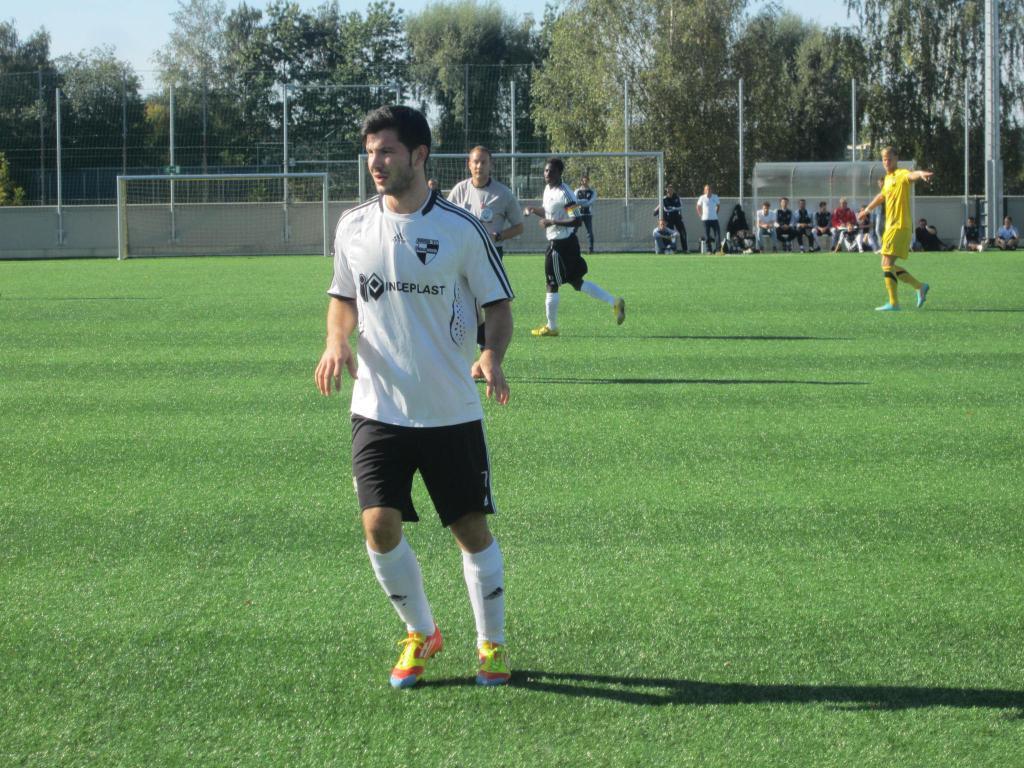Can you describe this image briefly? In the image we can see there are people standing on the ground and the ground is covered with grass. There are other people sitting on the bench and there are iron poles and iron fencing. There is net at the back and behind there are lot of trees. 